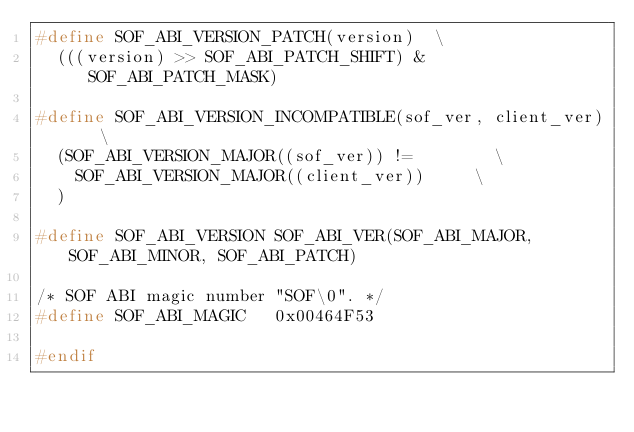<code> <loc_0><loc_0><loc_500><loc_500><_C_>#define SOF_ABI_VERSION_PATCH(version)	\
	(((version) >> SOF_ABI_PATCH_SHIFT) & SOF_ABI_PATCH_MASK)

#define SOF_ABI_VERSION_INCOMPATIBLE(sof_ver, client_ver)		\
	(SOF_ABI_VERSION_MAJOR((sof_ver)) !=				\
		SOF_ABI_VERSION_MAJOR((client_ver))			\
	)

#define SOF_ABI_VERSION SOF_ABI_VER(SOF_ABI_MAJOR, SOF_ABI_MINOR, SOF_ABI_PATCH)

/* SOF ABI magic number "SOF\0". */
#define SOF_ABI_MAGIC		0x00464F53

#endif
</code> 